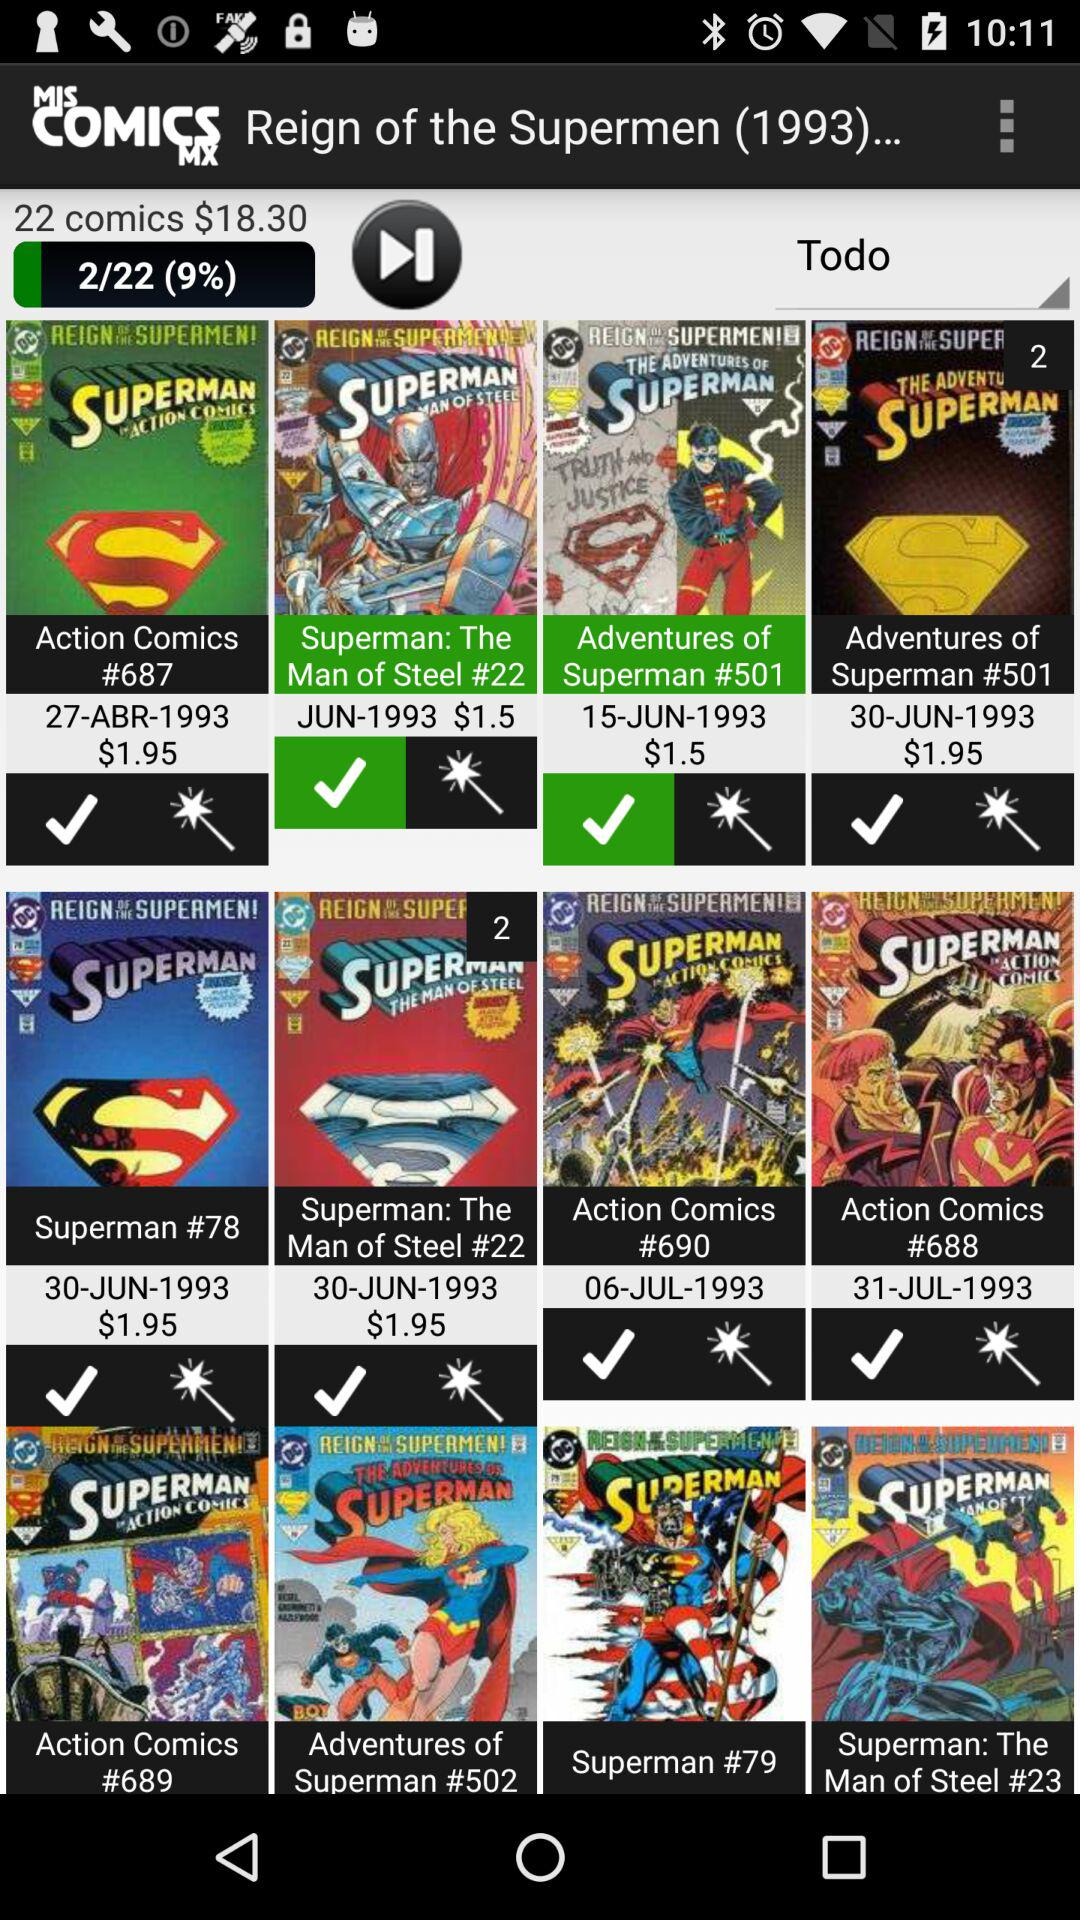What's the cost of 22 comics? The cost of 22 comics is $18.30. 